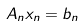Convert formula to latex. <formula><loc_0><loc_0><loc_500><loc_500>A _ { n } x _ { n } = b _ { n }</formula> 